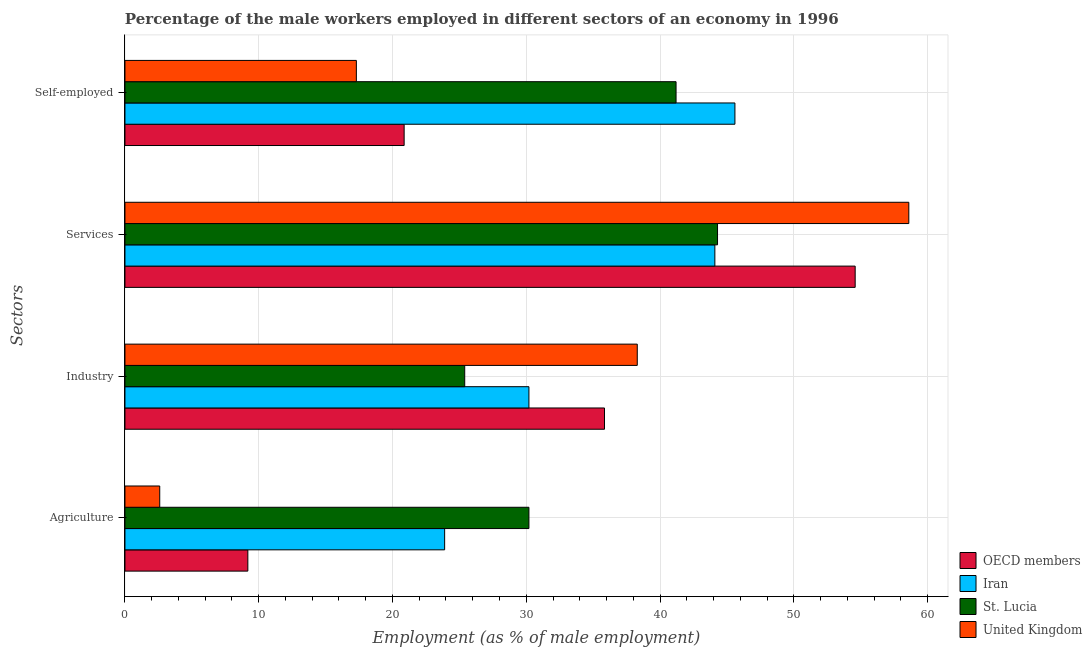How many different coloured bars are there?
Make the answer very short. 4. How many groups of bars are there?
Keep it short and to the point. 4. Are the number of bars per tick equal to the number of legend labels?
Your response must be concise. Yes. Are the number of bars on each tick of the Y-axis equal?
Keep it short and to the point. Yes. How many bars are there on the 3rd tick from the bottom?
Ensure brevity in your answer.  4. What is the label of the 2nd group of bars from the top?
Keep it short and to the point. Services. What is the percentage of self employed male workers in United Kingdom?
Give a very brief answer. 17.3. Across all countries, what is the maximum percentage of self employed male workers?
Make the answer very short. 45.6. Across all countries, what is the minimum percentage of male workers in agriculture?
Give a very brief answer. 2.6. In which country was the percentage of self employed male workers maximum?
Your answer should be compact. Iran. In which country was the percentage of male workers in services minimum?
Ensure brevity in your answer.  Iran. What is the total percentage of self employed male workers in the graph?
Provide a succinct answer. 124.97. What is the difference between the percentage of male workers in agriculture in United Kingdom and that in St. Lucia?
Your response must be concise. -27.6. What is the difference between the percentage of male workers in services in St. Lucia and the percentage of male workers in industry in Iran?
Ensure brevity in your answer.  14.1. What is the average percentage of male workers in industry per country?
Ensure brevity in your answer.  32.44. What is the difference between the percentage of male workers in services and percentage of self employed male workers in United Kingdom?
Your answer should be compact. 41.3. In how many countries, is the percentage of male workers in services greater than 24 %?
Keep it short and to the point. 4. What is the ratio of the percentage of male workers in services in OECD members to that in Iran?
Provide a succinct answer. 1.24. Is the difference between the percentage of male workers in services in United Kingdom and OECD members greater than the difference between the percentage of male workers in agriculture in United Kingdom and OECD members?
Provide a short and direct response. Yes. What is the difference between the highest and the second highest percentage of self employed male workers?
Offer a terse response. 4.4. What is the difference between the highest and the lowest percentage of male workers in services?
Provide a succinct answer. 14.5. In how many countries, is the percentage of male workers in services greater than the average percentage of male workers in services taken over all countries?
Keep it short and to the point. 2. What does the 3rd bar from the top in Industry represents?
Your response must be concise. Iran. What does the 4th bar from the bottom in Services represents?
Provide a succinct answer. United Kingdom. Is it the case that in every country, the sum of the percentage of male workers in agriculture and percentage of male workers in industry is greater than the percentage of male workers in services?
Give a very brief answer. No. How many bars are there?
Your answer should be very brief. 16. Are all the bars in the graph horizontal?
Give a very brief answer. Yes. How many countries are there in the graph?
Your response must be concise. 4. What is the difference between two consecutive major ticks on the X-axis?
Give a very brief answer. 10. Are the values on the major ticks of X-axis written in scientific E-notation?
Your answer should be very brief. No. Does the graph contain any zero values?
Give a very brief answer. No. Does the graph contain grids?
Provide a short and direct response. Yes. How many legend labels are there?
Give a very brief answer. 4. How are the legend labels stacked?
Your answer should be compact. Vertical. What is the title of the graph?
Make the answer very short. Percentage of the male workers employed in different sectors of an economy in 1996. Does "South Asia" appear as one of the legend labels in the graph?
Give a very brief answer. No. What is the label or title of the X-axis?
Your answer should be very brief. Employment (as % of male employment). What is the label or title of the Y-axis?
Offer a very short reply. Sectors. What is the Employment (as % of male employment) of OECD members in Agriculture?
Give a very brief answer. 9.19. What is the Employment (as % of male employment) of Iran in Agriculture?
Provide a succinct answer. 23.9. What is the Employment (as % of male employment) in St. Lucia in Agriculture?
Provide a succinct answer. 30.2. What is the Employment (as % of male employment) of United Kingdom in Agriculture?
Provide a short and direct response. 2.6. What is the Employment (as % of male employment) of OECD members in Industry?
Your answer should be compact. 35.85. What is the Employment (as % of male employment) in Iran in Industry?
Ensure brevity in your answer.  30.2. What is the Employment (as % of male employment) of St. Lucia in Industry?
Your response must be concise. 25.4. What is the Employment (as % of male employment) of United Kingdom in Industry?
Your response must be concise. 38.3. What is the Employment (as % of male employment) of OECD members in Services?
Give a very brief answer. 54.59. What is the Employment (as % of male employment) in Iran in Services?
Make the answer very short. 44.1. What is the Employment (as % of male employment) in St. Lucia in Services?
Your response must be concise. 44.3. What is the Employment (as % of male employment) of United Kingdom in Services?
Make the answer very short. 58.6. What is the Employment (as % of male employment) of OECD members in Self-employed?
Ensure brevity in your answer.  20.87. What is the Employment (as % of male employment) of Iran in Self-employed?
Offer a very short reply. 45.6. What is the Employment (as % of male employment) in St. Lucia in Self-employed?
Provide a short and direct response. 41.2. What is the Employment (as % of male employment) in United Kingdom in Self-employed?
Provide a succinct answer. 17.3. Across all Sectors, what is the maximum Employment (as % of male employment) in OECD members?
Your response must be concise. 54.59. Across all Sectors, what is the maximum Employment (as % of male employment) in Iran?
Your answer should be very brief. 45.6. Across all Sectors, what is the maximum Employment (as % of male employment) in St. Lucia?
Offer a very short reply. 44.3. Across all Sectors, what is the maximum Employment (as % of male employment) in United Kingdom?
Offer a very short reply. 58.6. Across all Sectors, what is the minimum Employment (as % of male employment) in OECD members?
Give a very brief answer. 9.19. Across all Sectors, what is the minimum Employment (as % of male employment) of Iran?
Offer a very short reply. 23.9. Across all Sectors, what is the minimum Employment (as % of male employment) in St. Lucia?
Your answer should be very brief. 25.4. Across all Sectors, what is the minimum Employment (as % of male employment) of United Kingdom?
Your answer should be very brief. 2.6. What is the total Employment (as % of male employment) of OECD members in the graph?
Make the answer very short. 120.5. What is the total Employment (as % of male employment) in Iran in the graph?
Your answer should be very brief. 143.8. What is the total Employment (as % of male employment) in St. Lucia in the graph?
Give a very brief answer. 141.1. What is the total Employment (as % of male employment) in United Kingdom in the graph?
Give a very brief answer. 116.8. What is the difference between the Employment (as % of male employment) in OECD members in Agriculture and that in Industry?
Your answer should be compact. -26.66. What is the difference between the Employment (as % of male employment) in Iran in Agriculture and that in Industry?
Your answer should be very brief. -6.3. What is the difference between the Employment (as % of male employment) in St. Lucia in Agriculture and that in Industry?
Ensure brevity in your answer.  4.8. What is the difference between the Employment (as % of male employment) of United Kingdom in Agriculture and that in Industry?
Provide a short and direct response. -35.7. What is the difference between the Employment (as % of male employment) of OECD members in Agriculture and that in Services?
Ensure brevity in your answer.  -45.4. What is the difference between the Employment (as % of male employment) in Iran in Agriculture and that in Services?
Ensure brevity in your answer.  -20.2. What is the difference between the Employment (as % of male employment) of St. Lucia in Agriculture and that in Services?
Offer a terse response. -14.1. What is the difference between the Employment (as % of male employment) of United Kingdom in Agriculture and that in Services?
Your answer should be very brief. -56. What is the difference between the Employment (as % of male employment) in OECD members in Agriculture and that in Self-employed?
Your answer should be compact. -11.68. What is the difference between the Employment (as % of male employment) of Iran in Agriculture and that in Self-employed?
Offer a terse response. -21.7. What is the difference between the Employment (as % of male employment) of United Kingdom in Agriculture and that in Self-employed?
Provide a short and direct response. -14.7. What is the difference between the Employment (as % of male employment) of OECD members in Industry and that in Services?
Provide a succinct answer. -18.74. What is the difference between the Employment (as % of male employment) of St. Lucia in Industry and that in Services?
Offer a very short reply. -18.9. What is the difference between the Employment (as % of male employment) of United Kingdom in Industry and that in Services?
Provide a short and direct response. -20.3. What is the difference between the Employment (as % of male employment) in OECD members in Industry and that in Self-employed?
Make the answer very short. 14.98. What is the difference between the Employment (as % of male employment) of Iran in Industry and that in Self-employed?
Offer a very short reply. -15.4. What is the difference between the Employment (as % of male employment) of St. Lucia in Industry and that in Self-employed?
Offer a very short reply. -15.8. What is the difference between the Employment (as % of male employment) of OECD members in Services and that in Self-employed?
Make the answer very short. 33.72. What is the difference between the Employment (as % of male employment) of United Kingdom in Services and that in Self-employed?
Give a very brief answer. 41.3. What is the difference between the Employment (as % of male employment) of OECD members in Agriculture and the Employment (as % of male employment) of Iran in Industry?
Your answer should be compact. -21.01. What is the difference between the Employment (as % of male employment) in OECD members in Agriculture and the Employment (as % of male employment) in St. Lucia in Industry?
Offer a terse response. -16.21. What is the difference between the Employment (as % of male employment) in OECD members in Agriculture and the Employment (as % of male employment) in United Kingdom in Industry?
Make the answer very short. -29.11. What is the difference between the Employment (as % of male employment) in Iran in Agriculture and the Employment (as % of male employment) in St. Lucia in Industry?
Keep it short and to the point. -1.5. What is the difference between the Employment (as % of male employment) in Iran in Agriculture and the Employment (as % of male employment) in United Kingdom in Industry?
Offer a very short reply. -14.4. What is the difference between the Employment (as % of male employment) in St. Lucia in Agriculture and the Employment (as % of male employment) in United Kingdom in Industry?
Your answer should be very brief. -8.1. What is the difference between the Employment (as % of male employment) of OECD members in Agriculture and the Employment (as % of male employment) of Iran in Services?
Your answer should be compact. -34.91. What is the difference between the Employment (as % of male employment) in OECD members in Agriculture and the Employment (as % of male employment) in St. Lucia in Services?
Keep it short and to the point. -35.11. What is the difference between the Employment (as % of male employment) of OECD members in Agriculture and the Employment (as % of male employment) of United Kingdom in Services?
Provide a succinct answer. -49.41. What is the difference between the Employment (as % of male employment) of Iran in Agriculture and the Employment (as % of male employment) of St. Lucia in Services?
Provide a succinct answer. -20.4. What is the difference between the Employment (as % of male employment) in Iran in Agriculture and the Employment (as % of male employment) in United Kingdom in Services?
Provide a short and direct response. -34.7. What is the difference between the Employment (as % of male employment) in St. Lucia in Agriculture and the Employment (as % of male employment) in United Kingdom in Services?
Your answer should be very brief. -28.4. What is the difference between the Employment (as % of male employment) in OECD members in Agriculture and the Employment (as % of male employment) in Iran in Self-employed?
Offer a terse response. -36.41. What is the difference between the Employment (as % of male employment) of OECD members in Agriculture and the Employment (as % of male employment) of St. Lucia in Self-employed?
Give a very brief answer. -32.01. What is the difference between the Employment (as % of male employment) of OECD members in Agriculture and the Employment (as % of male employment) of United Kingdom in Self-employed?
Your answer should be very brief. -8.11. What is the difference between the Employment (as % of male employment) in Iran in Agriculture and the Employment (as % of male employment) in St. Lucia in Self-employed?
Offer a very short reply. -17.3. What is the difference between the Employment (as % of male employment) of OECD members in Industry and the Employment (as % of male employment) of Iran in Services?
Provide a succinct answer. -8.25. What is the difference between the Employment (as % of male employment) in OECD members in Industry and the Employment (as % of male employment) in St. Lucia in Services?
Provide a succinct answer. -8.45. What is the difference between the Employment (as % of male employment) of OECD members in Industry and the Employment (as % of male employment) of United Kingdom in Services?
Your answer should be very brief. -22.75. What is the difference between the Employment (as % of male employment) of Iran in Industry and the Employment (as % of male employment) of St. Lucia in Services?
Provide a succinct answer. -14.1. What is the difference between the Employment (as % of male employment) in Iran in Industry and the Employment (as % of male employment) in United Kingdom in Services?
Give a very brief answer. -28.4. What is the difference between the Employment (as % of male employment) of St. Lucia in Industry and the Employment (as % of male employment) of United Kingdom in Services?
Your answer should be very brief. -33.2. What is the difference between the Employment (as % of male employment) in OECD members in Industry and the Employment (as % of male employment) in Iran in Self-employed?
Your answer should be very brief. -9.75. What is the difference between the Employment (as % of male employment) in OECD members in Industry and the Employment (as % of male employment) in St. Lucia in Self-employed?
Your answer should be very brief. -5.35. What is the difference between the Employment (as % of male employment) in OECD members in Industry and the Employment (as % of male employment) in United Kingdom in Self-employed?
Offer a very short reply. 18.55. What is the difference between the Employment (as % of male employment) of Iran in Industry and the Employment (as % of male employment) of St. Lucia in Self-employed?
Make the answer very short. -11. What is the difference between the Employment (as % of male employment) in Iran in Industry and the Employment (as % of male employment) in United Kingdom in Self-employed?
Provide a short and direct response. 12.9. What is the difference between the Employment (as % of male employment) of St. Lucia in Industry and the Employment (as % of male employment) of United Kingdom in Self-employed?
Offer a terse response. 8.1. What is the difference between the Employment (as % of male employment) of OECD members in Services and the Employment (as % of male employment) of Iran in Self-employed?
Keep it short and to the point. 8.99. What is the difference between the Employment (as % of male employment) of OECD members in Services and the Employment (as % of male employment) of St. Lucia in Self-employed?
Give a very brief answer. 13.39. What is the difference between the Employment (as % of male employment) in OECD members in Services and the Employment (as % of male employment) in United Kingdom in Self-employed?
Offer a terse response. 37.29. What is the difference between the Employment (as % of male employment) of Iran in Services and the Employment (as % of male employment) of St. Lucia in Self-employed?
Ensure brevity in your answer.  2.9. What is the difference between the Employment (as % of male employment) of Iran in Services and the Employment (as % of male employment) of United Kingdom in Self-employed?
Provide a succinct answer. 26.8. What is the average Employment (as % of male employment) of OECD members per Sectors?
Offer a terse response. 30.12. What is the average Employment (as % of male employment) of Iran per Sectors?
Offer a terse response. 35.95. What is the average Employment (as % of male employment) in St. Lucia per Sectors?
Offer a terse response. 35.27. What is the average Employment (as % of male employment) of United Kingdom per Sectors?
Your response must be concise. 29.2. What is the difference between the Employment (as % of male employment) of OECD members and Employment (as % of male employment) of Iran in Agriculture?
Your answer should be very brief. -14.71. What is the difference between the Employment (as % of male employment) of OECD members and Employment (as % of male employment) of St. Lucia in Agriculture?
Provide a succinct answer. -21.01. What is the difference between the Employment (as % of male employment) of OECD members and Employment (as % of male employment) of United Kingdom in Agriculture?
Your answer should be very brief. 6.59. What is the difference between the Employment (as % of male employment) of Iran and Employment (as % of male employment) of United Kingdom in Agriculture?
Provide a short and direct response. 21.3. What is the difference between the Employment (as % of male employment) of St. Lucia and Employment (as % of male employment) of United Kingdom in Agriculture?
Your answer should be compact. 27.6. What is the difference between the Employment (as % of male employment) in OECD members and Employment (as % of male employment) in Iran in Industry?
Provide a short and direct response. 5.65. What is the difference between the Employment (as % of male employment) in OECD members and Employment (as % of male employment) in St. Lucia in Industry?
Provide a short and direct response. 10.45. What is the difference between the Employment (as % of male employment) in OECD members and Employment (as % of male employment) in United Kingdom in Industry?
Your answer should be compact. -2.45. What is the difference between the Employment (as % of male employment) of Iran and Employment (as % of male employment) of United Kingdom in Industry?
Offer a very short reply. -8.1. What is the difference between the Employment (as % of male employment) in OECD members and Employment (as % of male employment) in Iran in Services?
Ensure brevity in your answer.  10.49. What is the difference between the Employment (as % of male employment) in OECD members and Employment (as % of male employment) in St. Lucia in Services?
Offer a very short reply. 10.29. What is the difference between the Employment (as % of male employment) in OECD members and Employment (as % of male employment) in United Kingdom in Services?
Keep it short and to the point. -4.01. What is the difference between the Employment (as % of male employment) of Iran and Employment (as % of male employment) of St. Lucia in Services?
Offer a terse response. -0.2. What is the difference between the Employment (as % of male employment) in Iran and Employment (as % of male employment) in United Kingdom in Services?
Your response must be concise. -14.5. What is the difference between the Employment (as % of male employment) in St. Lucia and Employment (as % of male employment) in United Kingdom in Services?
Your response must be concise. -14.3. What is the difference between the Employment (as % of male employment) in OECD members and Employment (as % of male employment) in Iran in Self-employed?
Offer a very short reply. -24.73. What is the difference between the Employment (as % of male employment) of OECD members and Employment (as % of male employment) of St. Lucia in Self-employed?
Offer a very short reply. -20.33. What is the difference between the Employment (as % of male employment) of OECD members and Employment (as % of male employment) of United Kingdom in Self-employed?
Your response must be concise. 3.57. What is the difference between the Employment (as % of male employment) in Iran and Employment (as % of male employment) in United Kingdom in Self-employed?
Ensure brevity in your answer.  28.3. What is the difference between the Employment (as % of male employment) of St. Lucia and Employment (as % of male employment) of United Kingdom in Self-employed?
Keep it short and to the point. 23.9. What is the ratio of the Employment (as % of male employment) of OECD members in Agriculture to that in Industry?
Provide a succinct answer. 0.26. What is the ratio of the Employment (as % of male employment) of Iran in Agriculture to that in Industry?
Provide a succinct answer. 0.79. What is the ratio of the Employment (as % of male employment) of St. Lucia in Agriculture to that in Industry?
Keep it short and to the point. 1.19. What is the ratio of the Employment (as % of male employment) of United Kingdom in Agriculture to that in Industry?
Keep it short and to the point. 0.07. What is the ratio of the Employment (as % of male employment) in OECD members in Agriculture to that in Services?
Give a very brief answer. 0.17. What is the ratio of the Employment (as % of male employment) in Iran in Agriculture to that in Services?
Offer a very short reply. 0.54. What is the ratio of the Employment (as % of male employment) of St. Lucia in Agriculture to that in Services?
Your response must be concise. 0.68. What is the ratio of the Employment (as % of male employment) in United Kingdom in Agriculture to that in Services?
Offer a very short reply. 0.04. What is the ratio of the Employment (as % of male employment) in OECD members in Agriculture to that in Self-employed?
Make the answer very short. 0.44. What is the ratio of the Employment (as % of male employment) in Iran in Agriculture to that in Self-employed?
Offer a terse response. 0.52. What is the ratio of the Employment (as % of male employment) in St. Lucia in Agriculture to that in Self-employed?
Keep it short and to the point. 0.73. What is the ratio of the Employment (as % of male employment) of United Kingdom in Agriculture to that in Self-employed?
Your answer should be compact. 0.15. What is the ratio of the Employment (as % of male employment) in OECD members in Industry to that in Services?
Keep it short and to the point. 0.66. What is the ratio of the Employment (as % of male employment) of Iran in Industry to that in Services?
Your response must be concise. 0.68. What is the ratio of the Employment (as % of male employment) in St. Lucia in Industry to that in Services?
Your response must be concise. 0.57. What is the ratio of the Employment (as % of male employment) in United Kingdom in Industry to that in Services?
Make the answer very short. 0.65. What is the ratio of the Employment (as % of male employment) in OECD members in Industry to that in Self-employed?
Your answer should be compact. 1.72. What is the ratio of the Employment (as % of male employment) in Iran in Industry to that in Self-employed?
Your answer should be compact. 0.66. What is the ratio of the Employment (as % of male employment) in St. Lucia in Industry to that in Self-employed?
Your response must be concise. 0.62. What is the ratio of the Employment (as % of male employment) in United Kingdom in Industry to that in Self-employed?
Provide a short and direct response. 2.21. What is the ratio of the Employment (as % of male employment) in OECD members in Services to that in Self-employed?
Offer a terse response. 2.62. What is the ratio of the Employment (as % of male employment) of Iran in Services to that in Self-employed?
Keep it short and to the point. 0.97. What is the ratio of the Employment (as % of male employment) in St. Lucia in Services to that in Self-employed?
Offer a very short reply. 1.08. What is the ratio of the Employment (as % of male employment) in United Kingdom in Services to that in Self-employed?
Give a very brief answer. 3.39. What is the difference between the highest and the second highest Employment (as % of male employment) of OECD members?
Your response must be concise. 18.74. What is the difference between the highest and the second highest Employment (as % of male employment) of United Kingdom?
Provide a succinct answer. 20.3. What is the difference between the highest and the lowest Employment (as % of male employment) in OECD members?
Provide a short and direct response. 45.4. What is the difference between the highest and the lowest Employment (as % of male employment) in Iran?
Give a very brief answer. 21.7. 